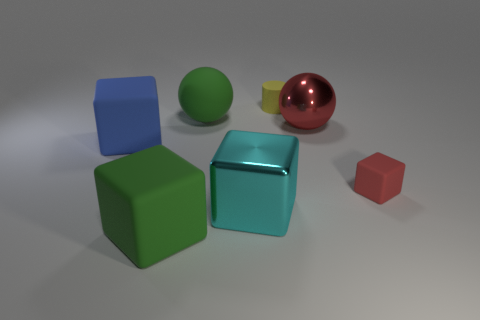Subtract all green cubes. How many cubes are left? 3 Add 3 large cyan metallic objects. How many objects exist? 10 Subtract all green spheres. How many spheres are left? 1 Subtract all cylinders. How many objects are left? 6 Subtract 1 cubes. How many cubes are left? 3 Subtract all yellow cubes. Subtract all green balls. How many cubes are left? 4 Subtract all brown spheres. How many purple cylinders are left? 0 Subtract all big blue rubber blocks. Subtract all metal things. How many objects are left? 4 Add 7 tiny yellow rubber things. How many tiny yellow rubber things are left? 8 Add 7 big cyan matte cylinders. How many big cyan matte cylinders exist? 7 